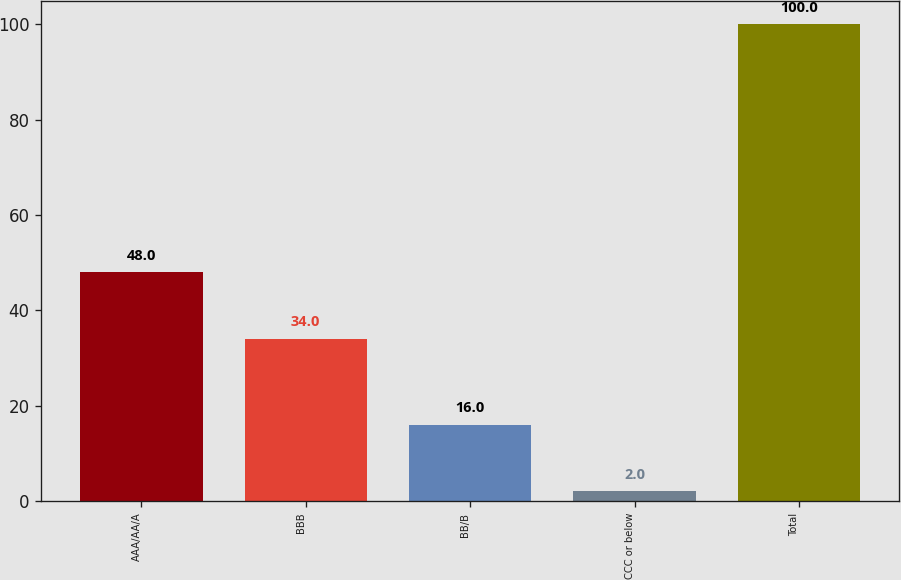Convert chart. <chart><loc_0><loc_0><loc_500><loc_500><bar_chart><fcel>AAA/AA/A<fcel>BBB<fcel>BB/B<fcel>CCC or below<fcel>Total<nl><fcel>48<fcel>34<fcel>16<fcel>2<fcel>100<nl></chart> 